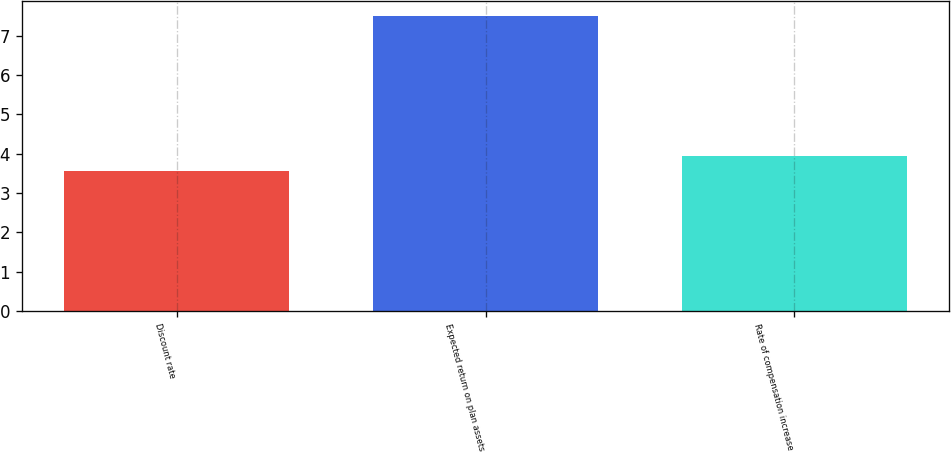Convert chart to OTSL. <chart><loc_0><loc_0><loc_500><loc_500><bar_chart><fcel>Discount rate<fcel>Expected return on plan assets<fcel>Rate of compensation increase<nl><fcel>3.56<fcel>7.5<fcel>3.95<nl></chart> 